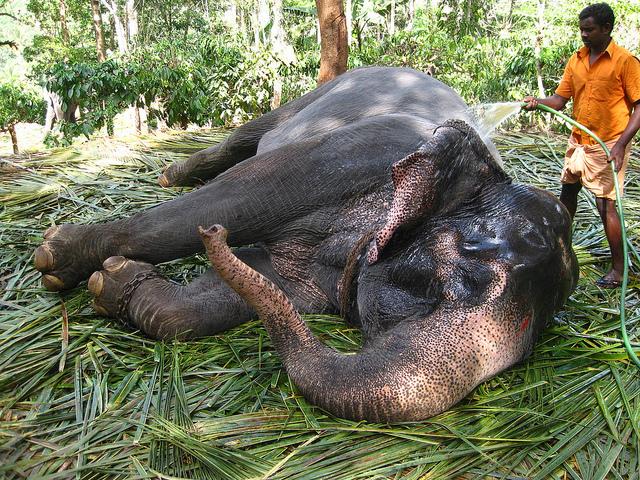Is this a baby elephant?
Concise answer only. No. What is restraining the animal?
Keep it brief. Chain. Is it lying down?
Give a very brief answer. Yes. 